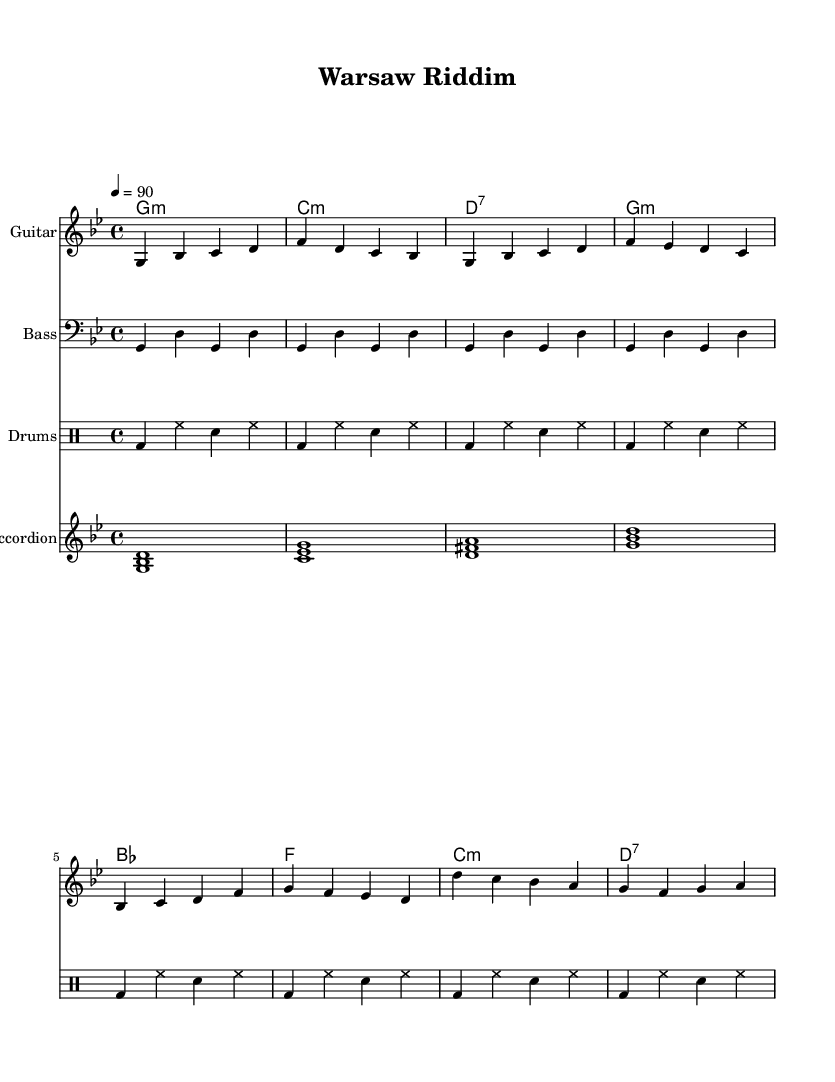What is the key signature of this music? The key signature is G minor, which has two flats (B♭ and E♭) indicated at the beginning of the staff.
Answer: G minor What is the time signature of this music? The time signature shown at the beginning is 4/4, which means that there are four beats in each measure and a quarter note receives one beat.
Answer: 4/4 What is the tempo marking for this piece? The tempo marking indicates a speed of 90 beats per minute (4 = 90), specifying how fast the music should be played.
Answer: 90 How many sections are there in the melody? The melody consists of three distinct sections: an introduction, a verse, and a chorus, plus an additional Polish folk melody section.
Answer: Four What instrument plays the Polish folk melody? The Polish folk melody is played by the accordion, as indicated by its dedicated staff in the score.
Answer: Accordion What type of rhythm pattern is used in the drums? The drum part features a repeating pattern of bass drum and snare drum on the first and third beats, with hi-hats played consistently.
Answer: Repeating pattern What is the genre of this piece? The features of the music, including the fusion of reggae rhythms with Polish folk melodies and instruments, classify the piece as Reggae fusion.
Answer: Reggae fusion 